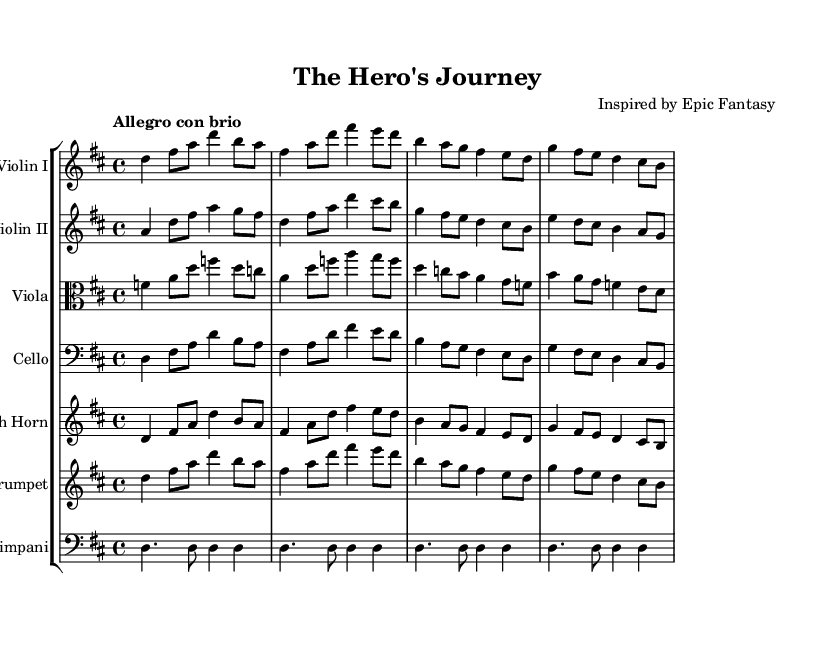What is the key signature of this music? The key signature is D major, which has two sharps (F# and C#). This can be identified by looking at the key signature at the beginning of the sheet music.
Answer: D major What is the time signature of this music? The time signature is 4/4, which means there are four beats in each measure and the quarter note gets the beat. This is indicated in the sheet music right after the key signature.
Answer: 4/4 What is the tempo marking for this piece? The tempo marking is "Allegro con brio," which translates to a lively and spirited tempo. This marking is found at the beginning of the score and helps performers understand how fast to play.
Answer: Allegro con brio How many measures are in the piece? There are 12 measures in total, which can be counted by looking at the notation in the music, as each horizontal line represents a measure.
Answer: 12 What instruments are included in this score? The score includes Violin I, Violin II, Viola, Cello, French Horn, Trumpet, and Timpani. These instruments can be identified at the beginning of each staff in the score.
Answer: Violin I, Violin II, Viola, Cello, French Horn, Trumpet, Timpani Which instruments play the same notes during the first measure? Violin I and Cello play the same notes during the first measure, as the pitches are written identically for both instruments. This can be observed by comparing the notes in their respective staves for that measure.
Answer: Violin I, Cello 